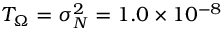Convert formula to latex. <formula><loc_0><loc_0><loc_500><loc_500>T _ { \Omega } = \sigma _ { N } ^ { 2 } = 1 . 0 \times 1 0 ^ { - 8 }</formula> 